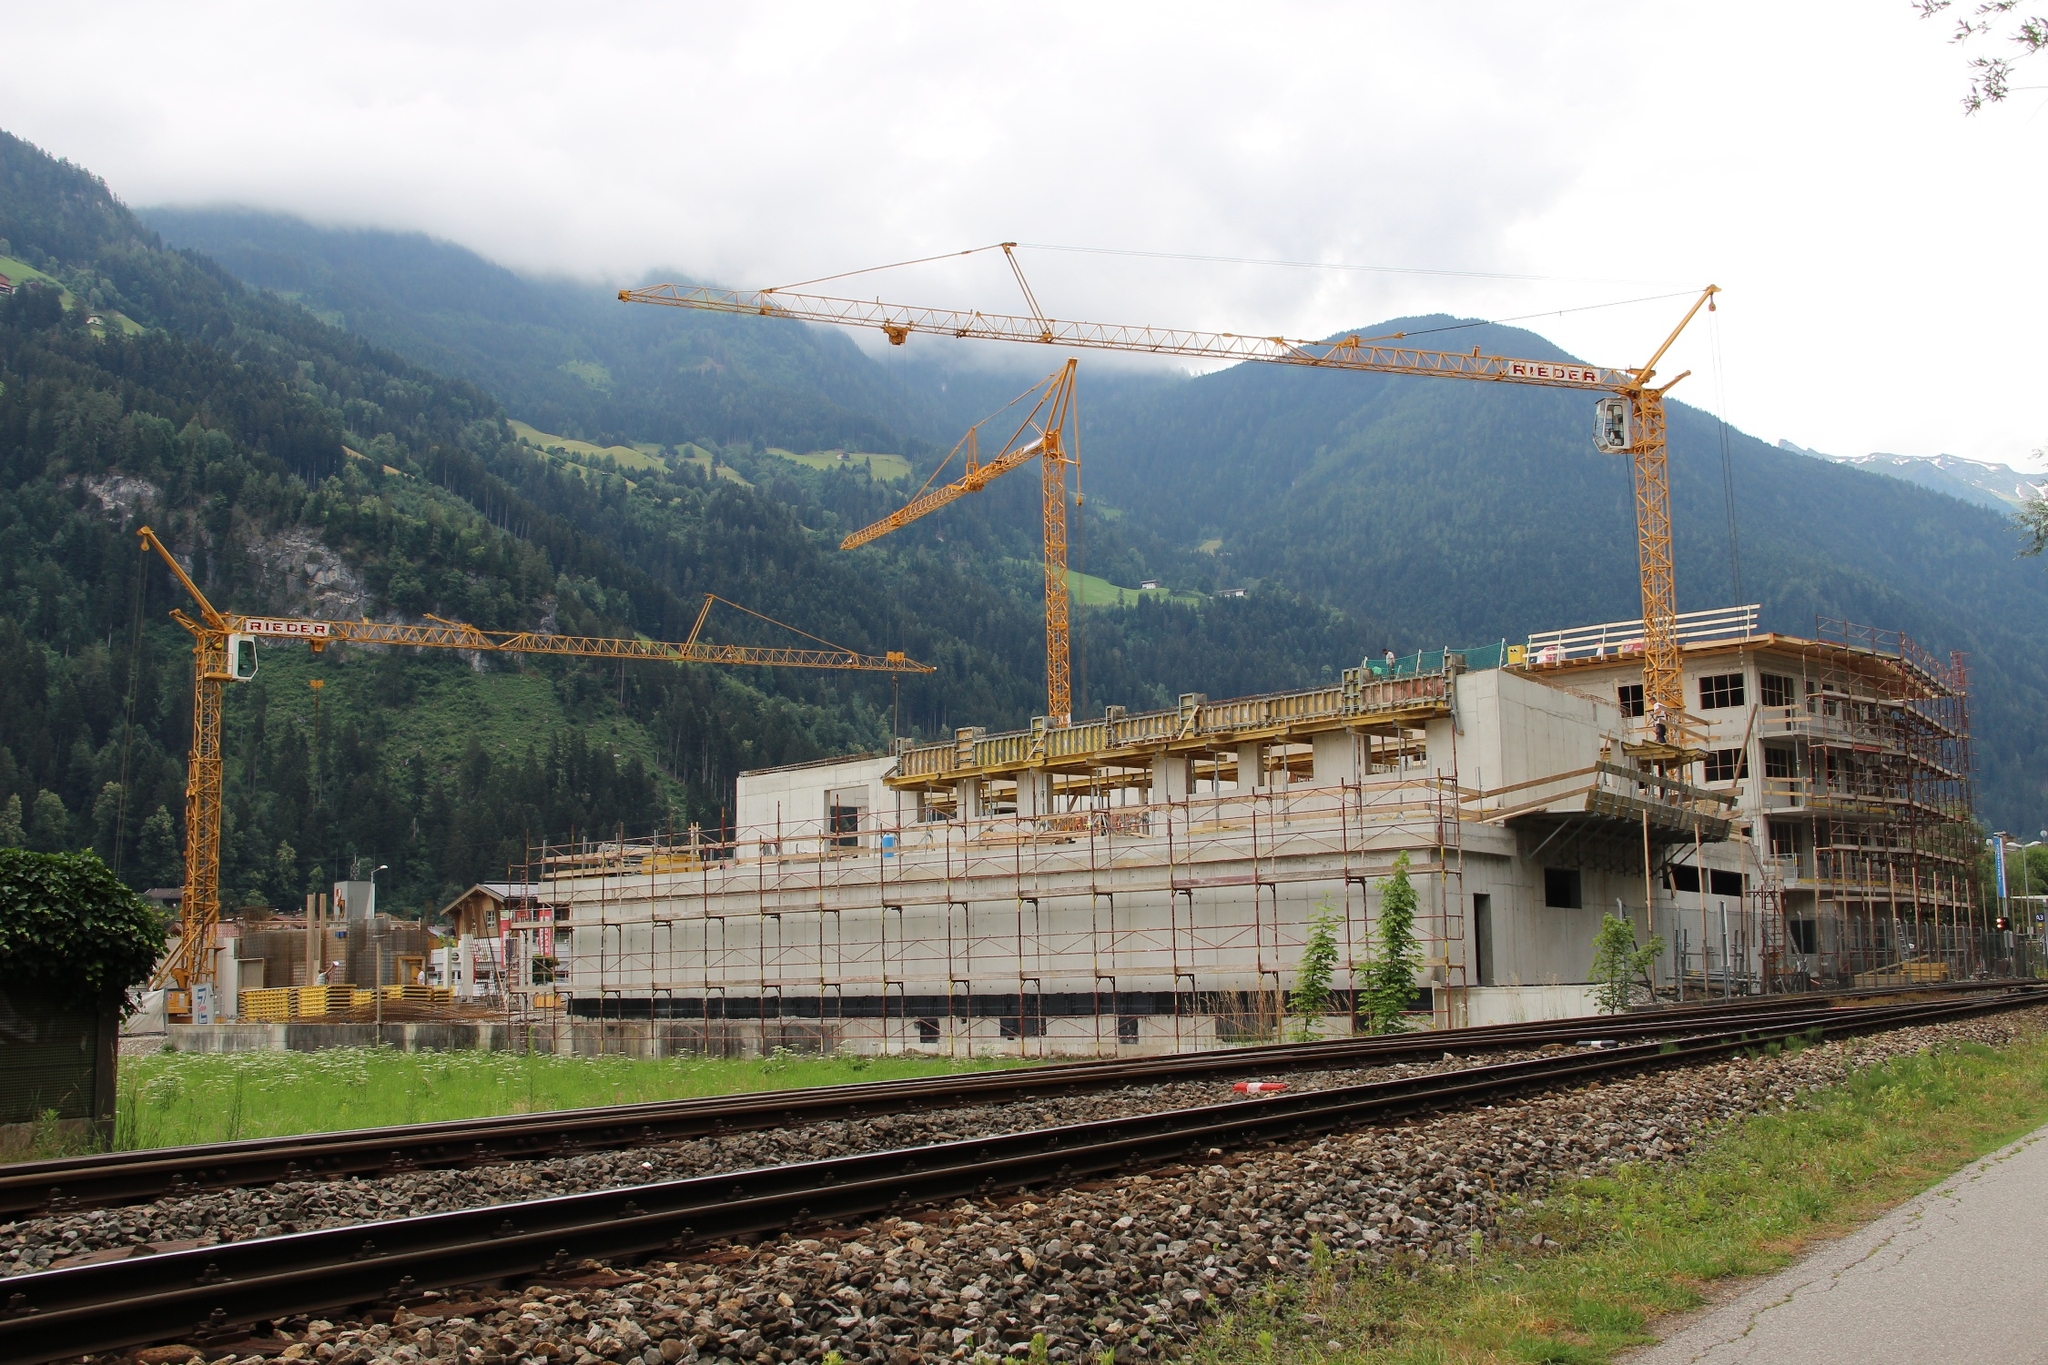Can you provide a more casual summary of the image? Sure! The image shows a busy construction site in the middle of some beautiful mountains. There are cranes working on a new building, with lots of green trees around it. There's also a train track running in front of the site. 